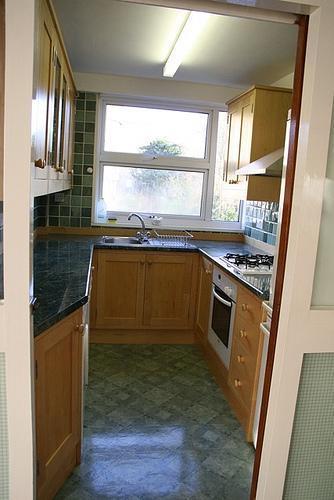How many people are in the image?
Give a very brief answer. 0. 